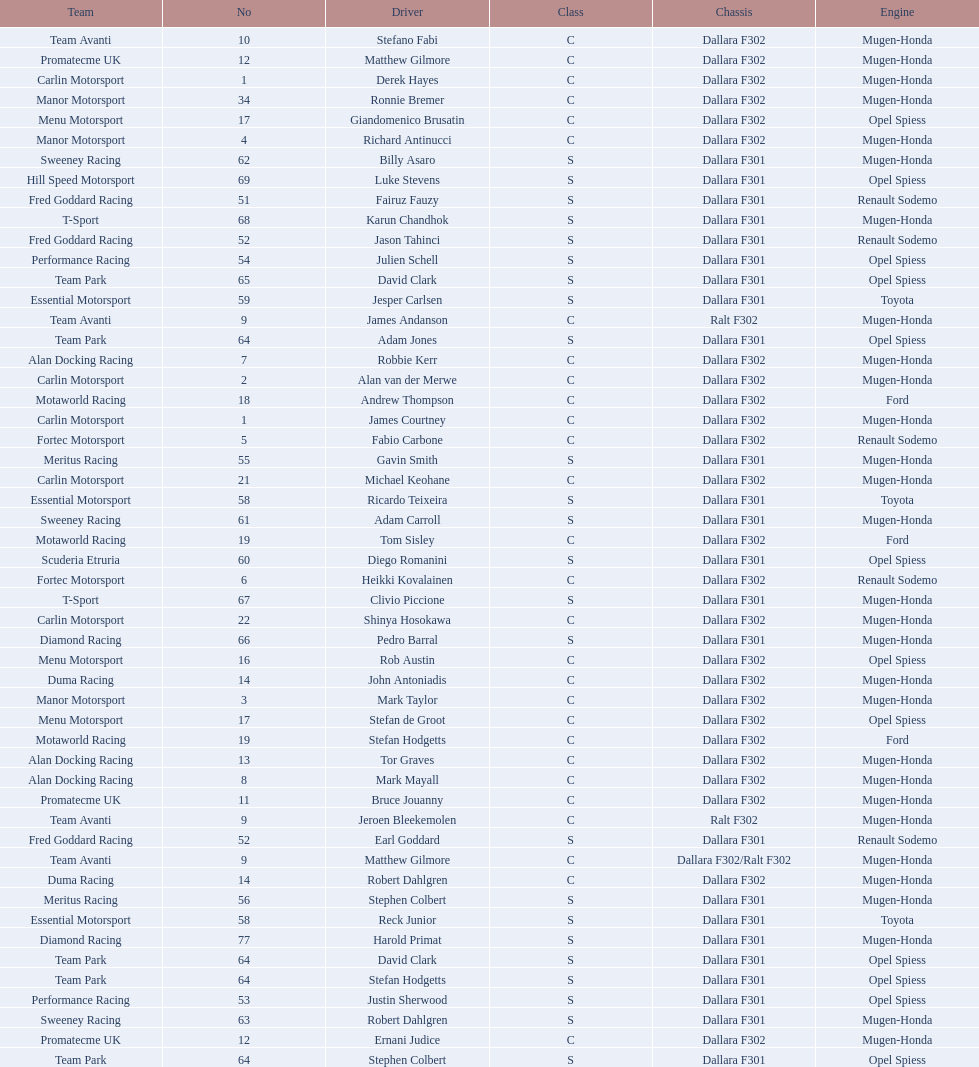Which engine was used the most by teams this season? Mugen-Honda. 